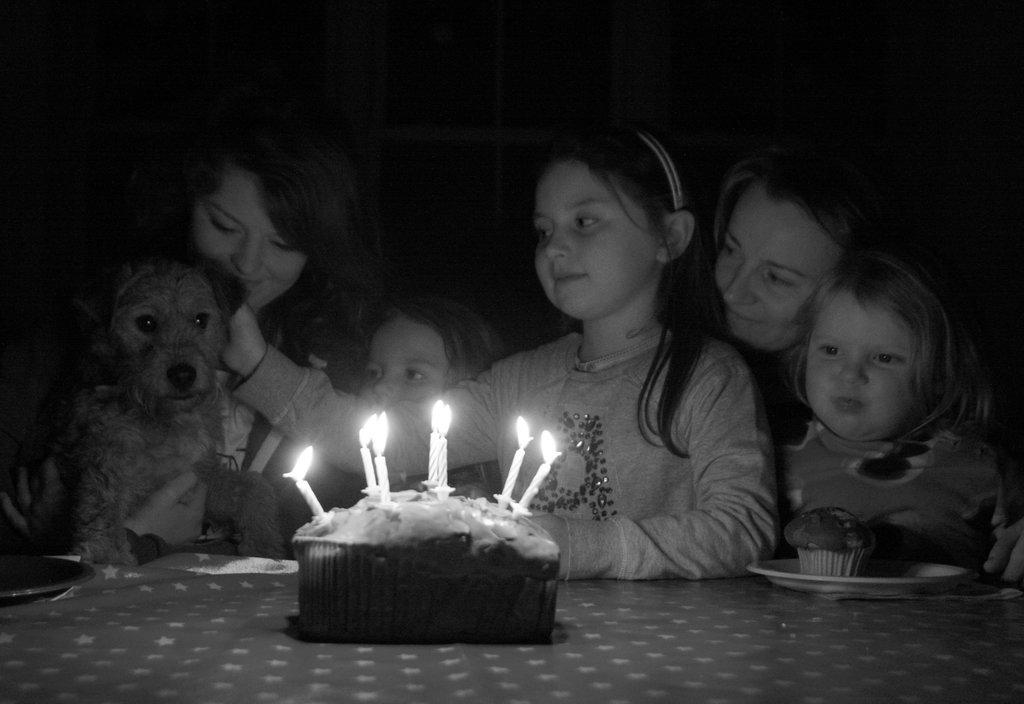What is happening in the image involving the group of kids? The kids are blowing candles in the image. Can you describe the presence of an animal in the image? Yes, there is a puppy in the image. What type of zephyr can be seen playing with a fork in the image? There is no zephyr or fork present in the image. How many snails are crawling on the puppy in the image? There are no snails present in the image; it only features a group of kids, candles, and a puppy. 